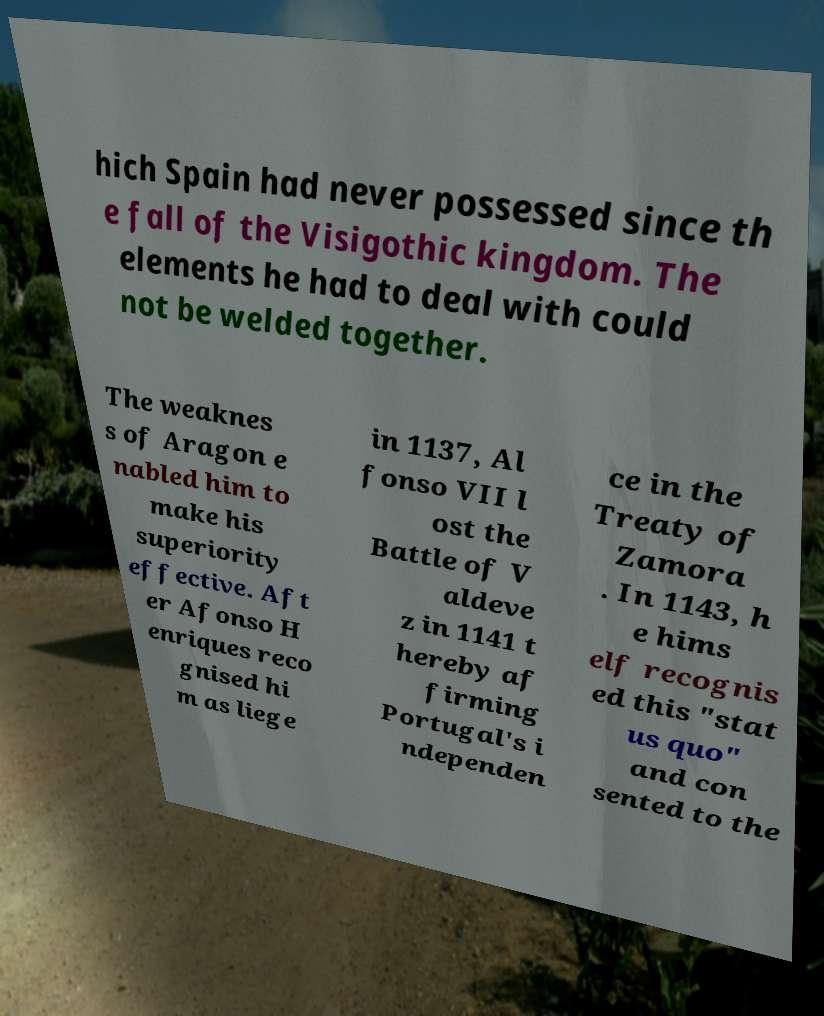Could you extract and type out the text from this image? hich Spain had never possessed since th e fall of the Visigothic kingdom. The elements he had to deal with could not be welded together. The weaknes s of Aragon e nabled him to make his superiority effective. Aft er Afonso H enriques reco gnised hi m as liege in 1137, Al fonso VII l ost the Battle of V aldeve z in 1141 t hereby af firming Portugal's i ndependen ce in the Treaty of Zamora . In 1143, h e hims elf recognis ed this "stat us quo" and con sented to the 